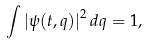<formula> <loc_0><loc_0><loc_500><loc_500>\int \left | \psi ( t , q ) \right | ^ { 2 } d q = 1 ,</formula> 